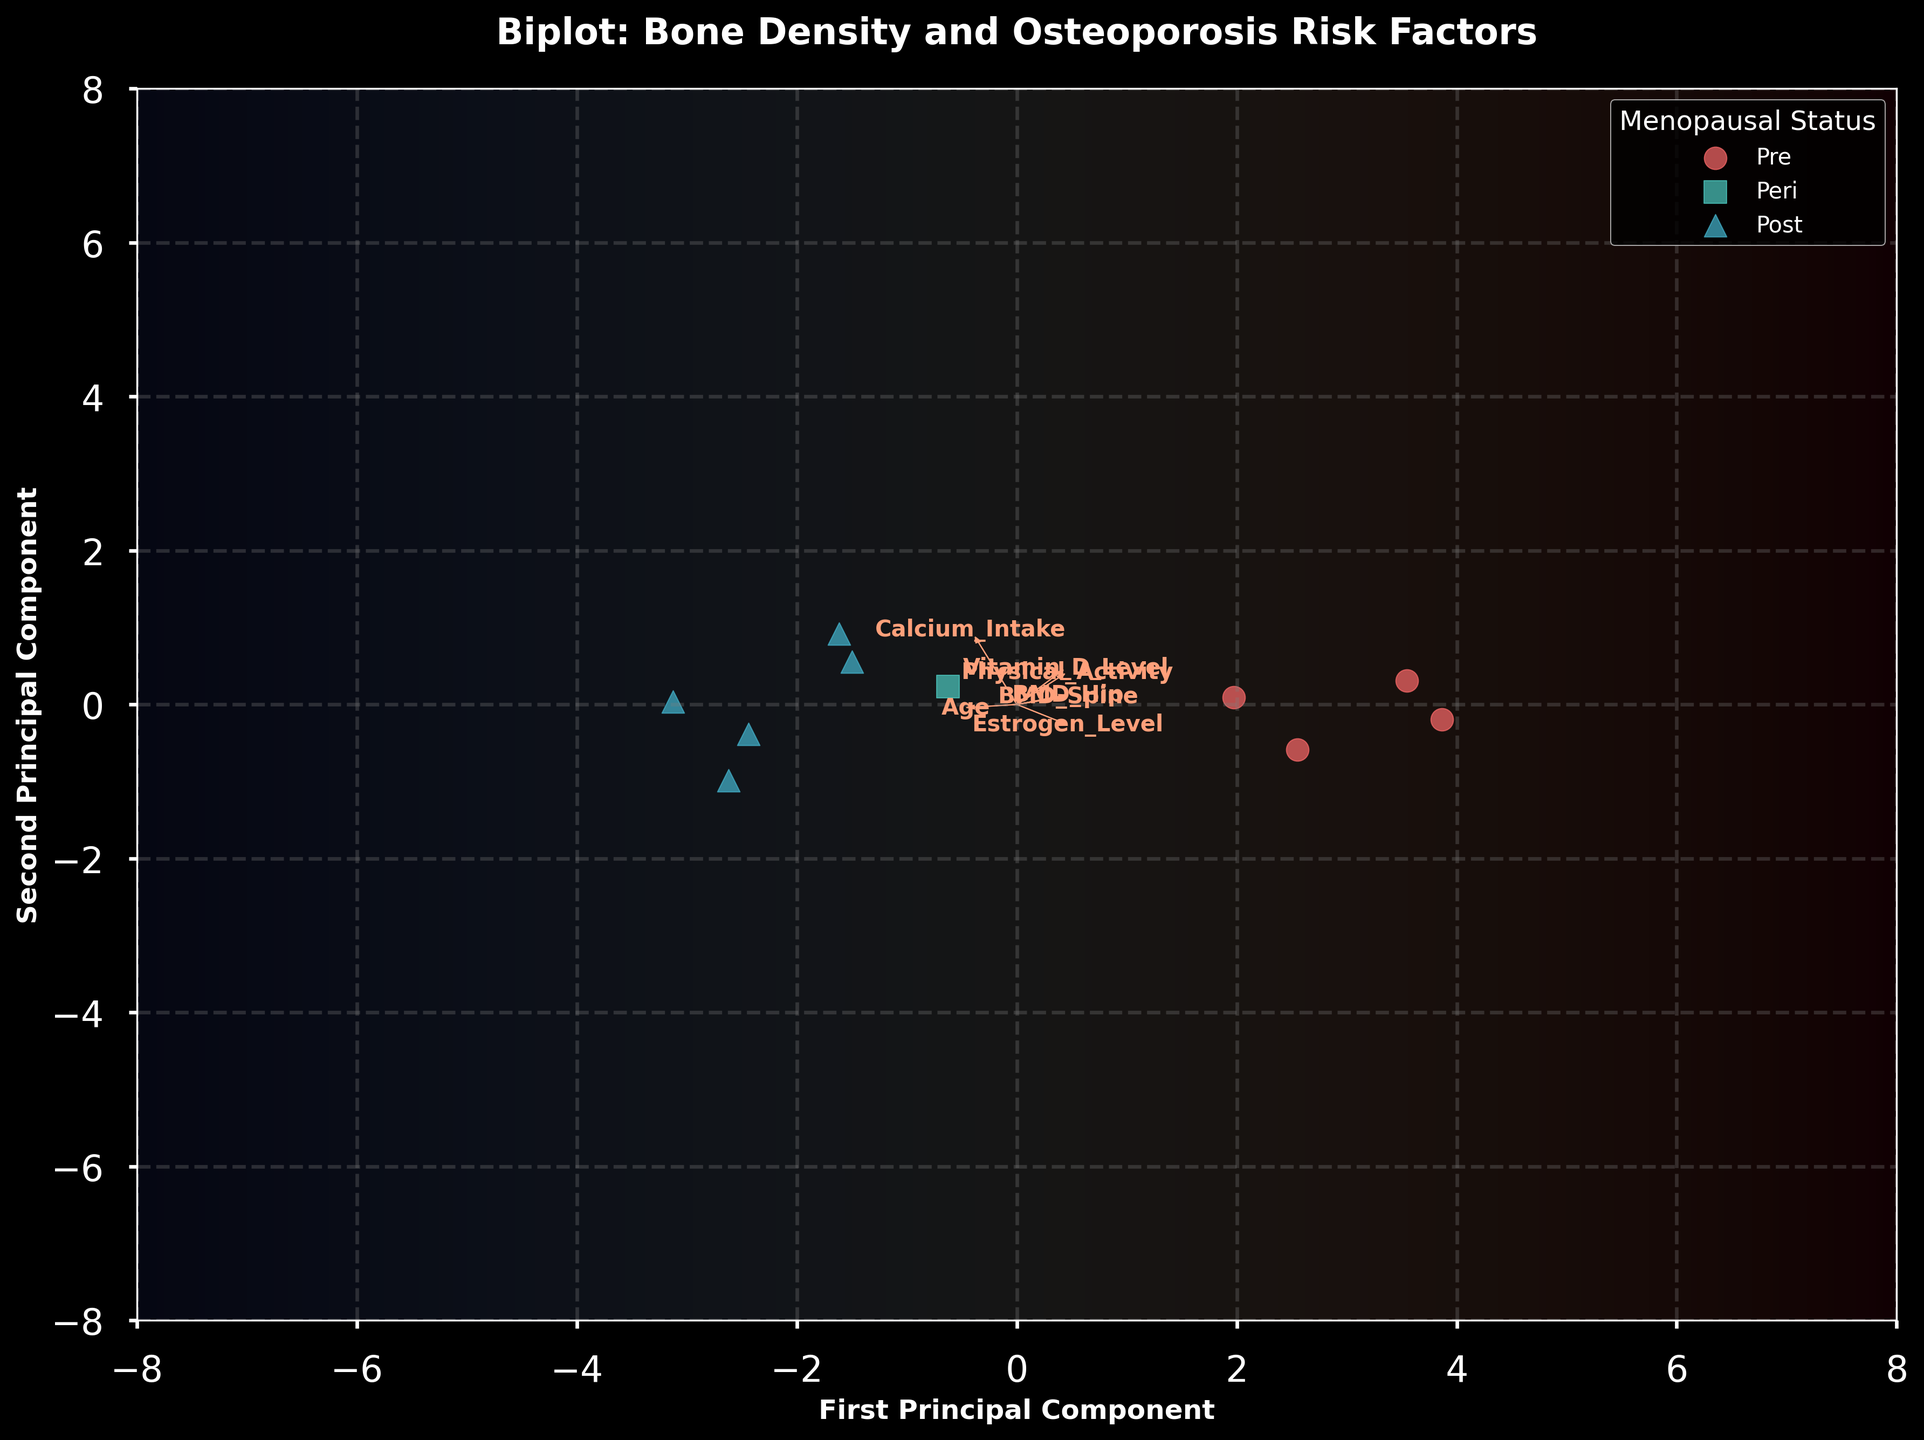What is the title of the figure? The title of the figure is positioned at the top of the plot and often describes what the biplot represents.
Answer: Biplot: Bone Density and Osteoporosis Risk Factors Which color represents post-menopausal women in the plot? The legend in the figure uses different colors for different menopausal statuses. The color for post-menopausal women is identified there.
Answer: Blue (approximately) How many pre-menopausal women are included in the plot? By looking at the plot, you can count the number of points corresponding to pre-menopausal women, which are indicated by circles of a particular color.
Answer: Four What is the relationship between "Estrogen_Level" and the first principal component? This can be observed by checking the direction and length of the arrow for "Estrogen_Level" in the plot, which indicates its correlation with the first principal component.
Answer: Positively correlated Which feature is more associated with the second principal component, "Age" or "Vitamin_D_Level"? The relative significance of each feature on the second principal component can be determined by comparing the angles and lengths of the arrows of "Age" and "Vitamin_D_Level". The one pointing more strongly in the direction of the second principal component would be more associated.
Answer: Vitamin_D_Level Which menopausal group shows the most variation along the first principal component? By examining the distribution of the data points along the first principal component for each menopausal group, the group with points spread most widely has the most variation.
Answer: Pre-menopausal Of the factors shown, which has the strongest influence in a positive direction on the second principal component? By observing the direction and length of the arrows in the biplot, the factor whose arrow is longest and most aligned with the positive direction of the second principal component will have the strongest positive influence.
Answer: Physical_Activity Between "BMD_Spine" and "BMD_Hip", which one has a stronger correlation with the second principal component? The strength of correlation of each feature with the second principal component can be inferred by comparing the lengths of their respective arrows along this component.
Answer: BMD_Hip How does the plot suggest post-menopausal status affects BMD measurements? This can be interpreted by examining the clustering of post-menopausal women’s data points and their position relative to the BMD-related feature vectors.
Answer: Post-menopausal women tend to cluster in regions with lower BMD values 